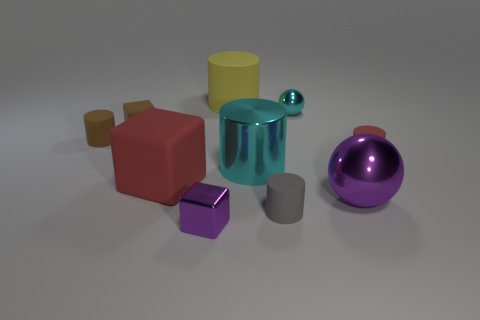Are there any brown rubber cylinders in front of the big red object?
Provide a short and direct response. No. What number of brown cylinders are behind the red thing on the left side of the small gray thing?
Your answer should be very brief. 1. What material is the cyan object that is the same size as the brown cylinder?
Keep it short and to the point. Metal. What number of other objects are there of the same material as the yellow object?
Provide a succinct answer. 5. There is a large rubber cylinder; how many brown cubes are to the right of it?
Provide a succinct answer. 0. How many cylinders are yellow things or tiny brown rubber objects?
Offer a very short reply. 2. What is the size of the cube that is both behind the small purple thing and in front of the small red rubber object?
Offer a very short reply. Large. How many other things are the same color as the small metal block?
Your answer should be compact. 1. Do the small cyan thing and the red thing that is on the left side of the big cyan shiny thing have the same material?
Ensure brevity in your answer.  No. How many things are either tiny cylinders that are on the right side of the cyan shiny sphere or tiny metal things?
Your answer should be very brief. 3. 